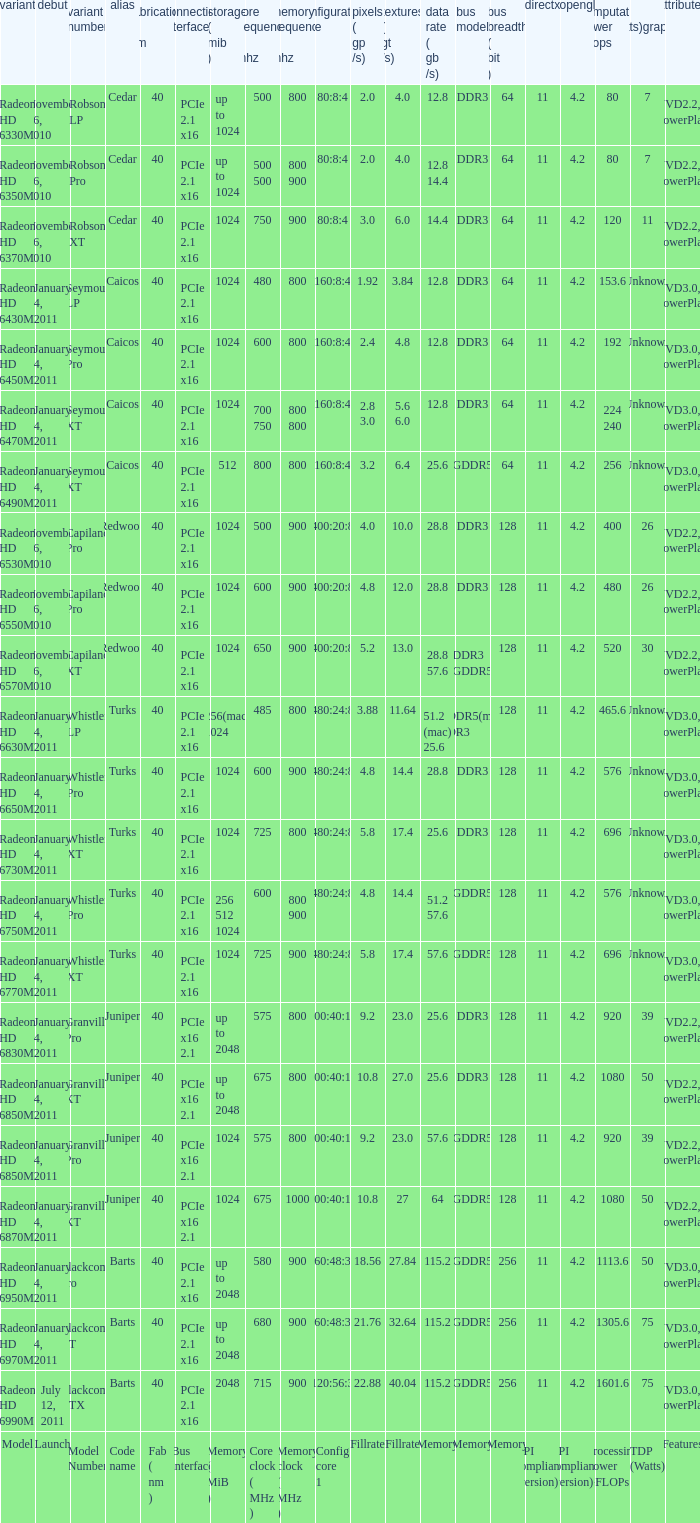How many values for bus width have a bandwidth of 25.6 and model number of Granville Pro? 1.0. 